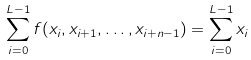<formula> <loc_0><loc_0><loc_500><loc_500>\sum _ { i = 0 } ^ { L - 1 } f ( x _ { i } , x _ { i + 1 } , \dots , x _ { i + n - 1 } ) = \sum _ { i = 0 } ^ { L - 1 } x _ { i }</formula> 